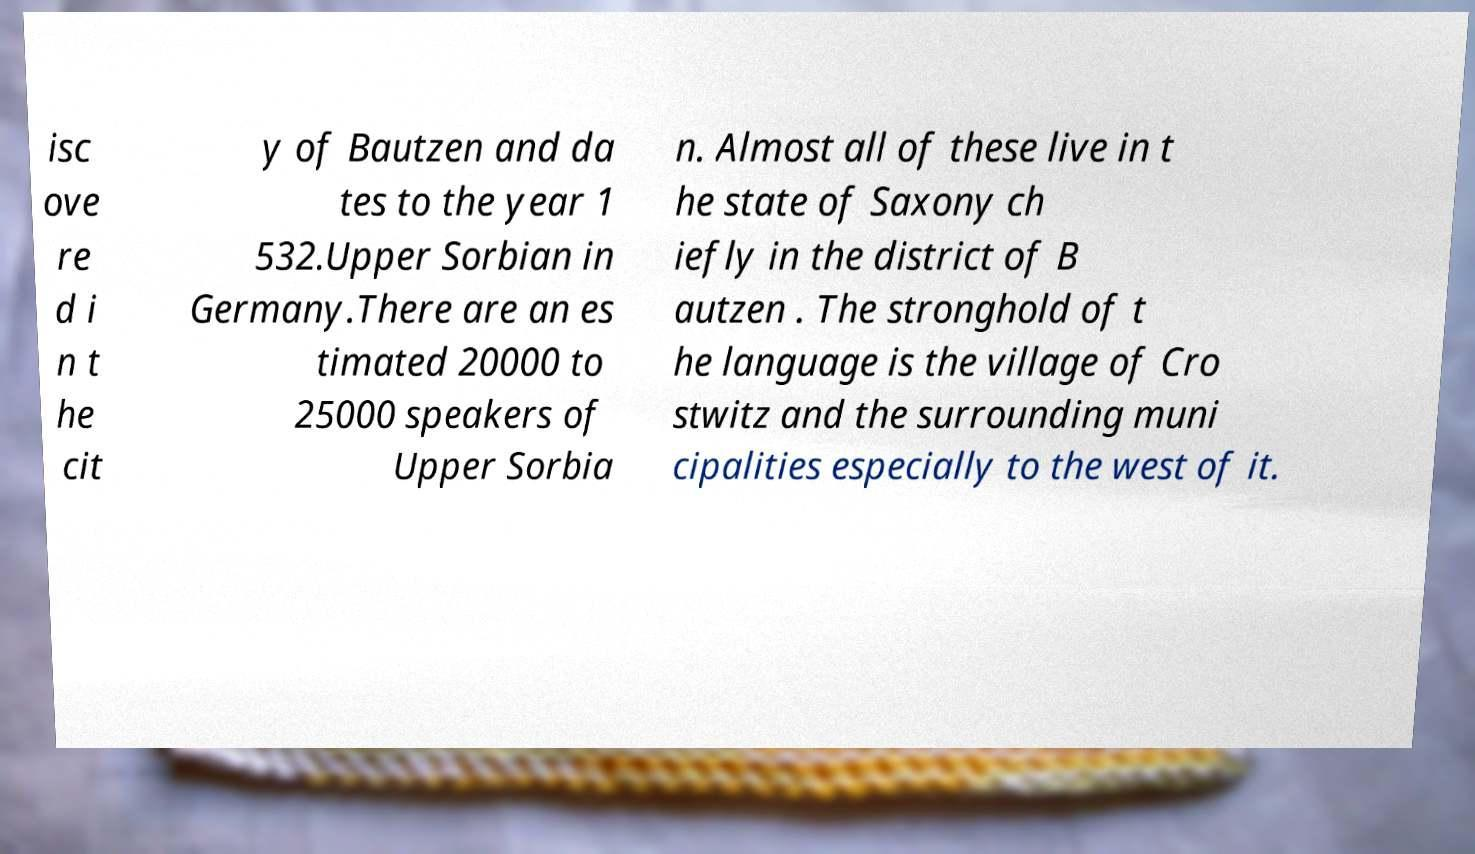Can you read and provide the text displayed in the image?This photo seems to have some interesting text. Can you extract and type it out for me? isc ove re d i n t he cit y of Bautzen and da tes to the year 1 532.Upper Sorbian in Germany.There are an es timated 20000 to 25000 speakers of Upper Sorbia n. Almost all of these live in t he state of Saxony ch iefly in the district of B autzen . The stronghold of t he language is the village of Cro stwitz and the surrounding muni cipalities especially to the west of it. 